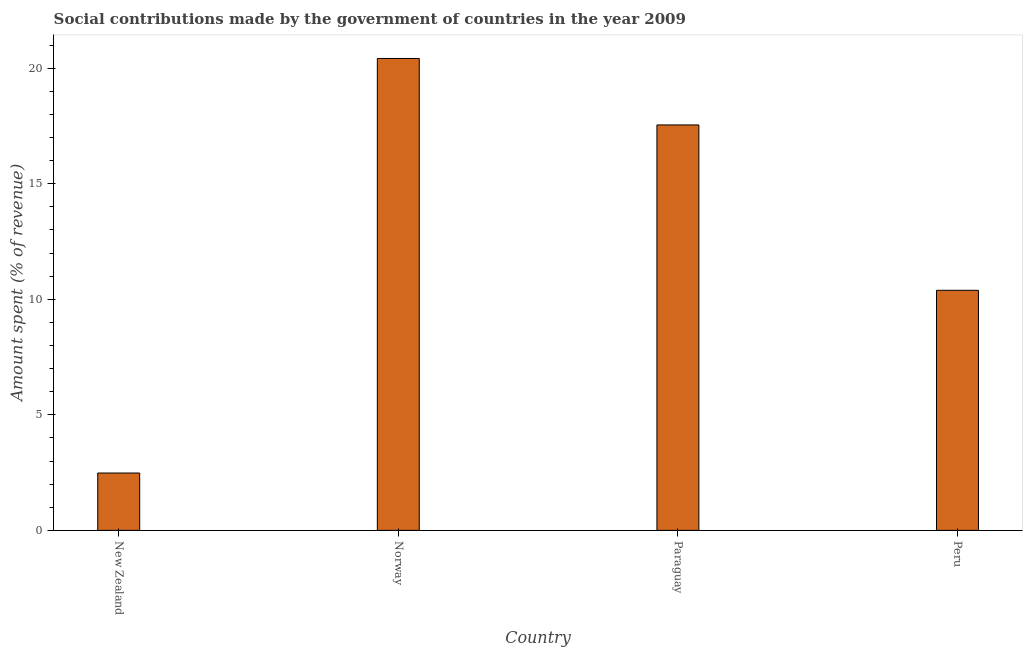Does the graph contain any zero values?
Your response must be concise. No. What is the title of the graph?
Provide a succinct answer. Social contributions made by the government of countries in the year 2009. What is the label or title of the X-axis?
Give a very brief answer. Country. What is the label or title of the Y-axis?
Offer a terse response. Amount spent (% of revenue). What is the amount spent in making social contributions in Norway?
Your response must be concise. 20.42. Across all countries, what is the maximum amount spent in making social contributions?
Ensure brevity in your answer.  20.42. Across all countries, what is the minimum amount spent in making social contributions?
Your response must be concise. 2.48. In which country was the amount spent in making social contributions maximum?
Give a very brief answer. Norway. In which country was the amount spent in making social contributions minimum?
Ensure brevity in your answer.  New Zealand. What is the sum of the amount spent in making social contributions?
Keep it short and to the point. 50.84. What is the difference between the amount spent in making social contributions in Norway and Paraguay?
Your response must be concise. 2.88. What is the average amount spent in making social contributions per country?
Offer a very short reply. 12.71. What is the median amount spent in making social contributions?
Your answer should be compact. 13.97. In how many countries, is the amount spent in making social contributions greater than 12 %?
Provide a short and direct response. 2. What is the ratio of the amount spent in making social contributions in New Zealand to that in Norway?
Your answer should be very brief. 0.12. What is the difference between the highest and the second highest amount spent in making social contributions?
Your answer should be compact. 2.88. Is the sum of the amount spent in making social contributions in New Zealand and Paraguay greater than the maximum amount spent in making social contributions across all countries?
Provide a short and direct response. No. What is the difference between the highest and the lowest amount spent in making social contributions?
Your answer should be compact. 17.94. In how many countries, is the amount spent in making social contributions greater than the average amount spent in making social contributions taken over all countries?
Ensure brevity in your answer.  2. Are all the bars in the graph horizontal?
Keep it short and to the point. No. Are the values on the major ticks of Y-axis written in scientific E-notation?
Your answer should be very brief. No. What is the Amount spent (% of revenue) in New Zealand?
Ensure brevity in your answer.  2.48. What is the Amount spent (% of revenue) in Norway?
Your response must be concise. 20.42. What is the Amount spent (% of revenue) in Paraguay?
Offer a terse response. 17.54. What is the Amount spent (% of revenue) of Peru?
Provide a succinct answer. 10.39. What is the difference between the Amount spent (% of revenue) in New Zealand and Norway?
Give a very brief answer. -17.94. What is the difference between the Amount spent (% of revenue) in New Zealand and Paraguay?
Your answer should be very brief. -15.06. What is the difference between the Amount spent (% of revenue) in New Zealand and Peru?
Offer a terse response. -7.91. What is the difference between the Amount spent (% of revenue) in Norway and Paraguay?
Your answer should be very brief. 2.88. What is the difference between the Amount spent (% of revenue) in Norway and Peru?
Your answer should be very brief. 10.03. What is the difference between the Amount spent (% of revenue) in Paraguay and Peru?
Your response must be concise. 7.16. What is the ratio of the Amount spent (% of revenue) in New Zealand to that in Norway?
Your answer should be very brief. 0.12. What is the ratio of the Amount spent (% of revenue) in New Zealand to that in Paraguay?
Your answer should be very brief. 0.14. What is the ratio of the Amount spent (% of revenue) in New Zealand to that in Peru?
Offer a very short reply. 0.24. What is the ratio of the Amount spent (% of revenue) in Norway to that in Paraguay?
Your answer should be compact. 1.16. What is the ratio of the Amount spent (% of revenue) in Norway to that in Peru?
Offer a very short reply. 1.97. What is the ratio of the Amount spent (% of revenue) in Paraguay to that in Peru?
Provide a short and direct response. 1.69. 